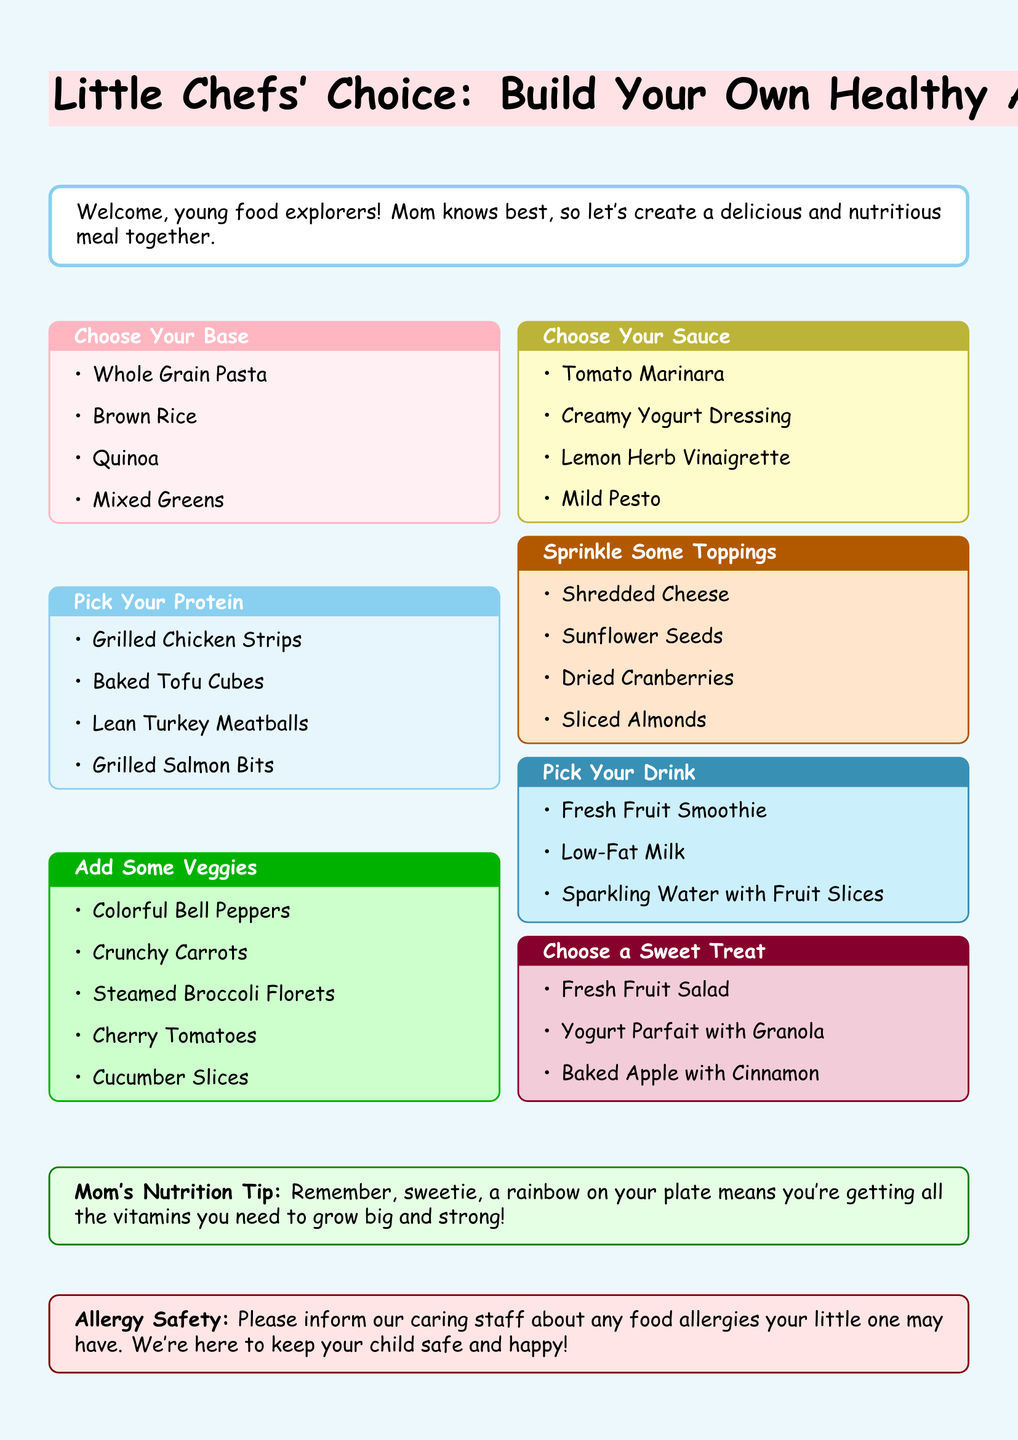What is the title of the children's menu? The title of the menu is highlighted in the document, stating the theme for kids to build their own meals.
Answer: Little Chefs' Choice: Build Your Own Healthy Adventure How many base options are available? The document lists the options under "Choose Your Base," providing the number of available choices.
Answer: 4 What is the protein option that includes plant-based food? The menu specifies various protein choices, and one of them is recognized as a plant-based option.
Answer: Baked Tofu Cubes Which vegetables can children add to their meals? The document lists various vegetables available for selection under "Add Some Veggies."
Answer: Colorful Bell Peppers, Crunchy Carrots, Steamed Broccoli Florets, Cherry Tomatoes, Cucumber Slices What drink options are provided for kids? The drinks available for selection are shown in the "Pick Your Drink" section of the menu.
Answer: Fresh Fruit Smoothie, Low-Fat Milk, Sparkling Water with Fruit Slices What is the main purpose of the customizable menu? The document emphasizes the intent behind the menu, designed for kids to make their own healthy meal choices.
Answer: Encourage healthy choices What sweet treat options are available? The menu offers a selection of sweet treats listed in the "Choose a Sweet Treat" section.
Answer: Fresh Fruit Salad, Yogurt Parfait with Granola, Baked Apple with Cinnamon What is Mom's Nutrition Tip? The menu contains a special health tip directed to children, encouraging healthy eating habits.
Answer: A rainbow on your plate means you're getting all the vitamins you need to grow big and strong! What should parents inform the staff about? The document includes an important note regarding children's safety that parents should be aware of when ordering.
Answer: Food allergies 